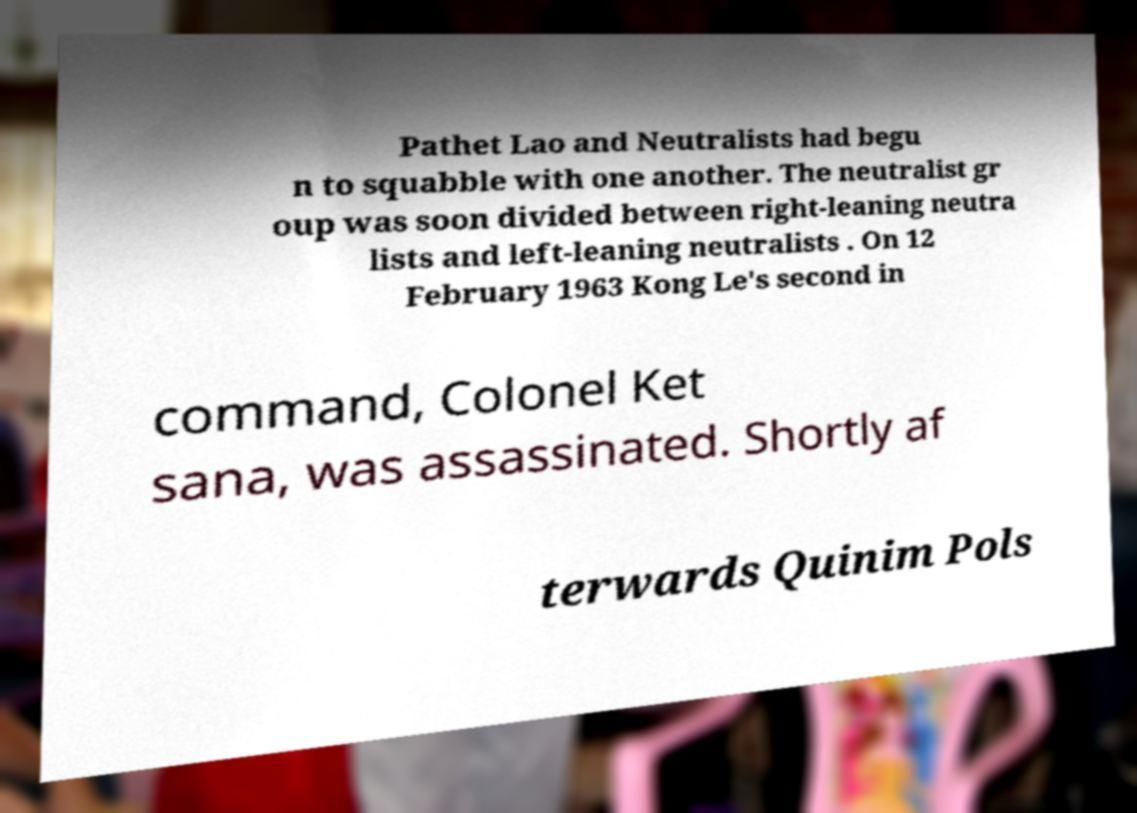Please identify and transcribe the text found in this image. Pathet Lao and Neutralists had begu n to squabble with one another. The neutralist gr oup was soon divided between right-leaning neutra lists and left-leaning neutralists . On 12 February 1963 Kong Le's second in command, Colonel Ket sana, was assassinated. Shortly af terwards Quinim Pols 